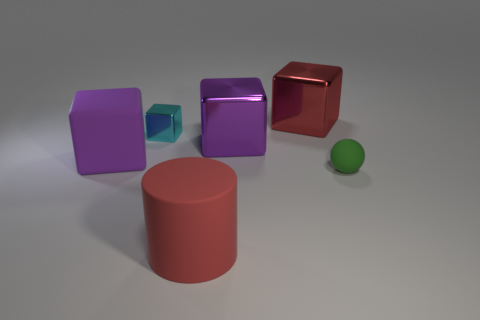There is a red metal block; are there any green matte objects behind it?
Offer a terse response. No. What material is the thing that is the same color as the matte cylinder?
Your response must be concise. Metal. Does the red thing that is in front of the tiny ball have the same material as the large red cube?
Your answer should be compact. No. Are there any big red metal blocks to the left of the rubber object that is behind the small object in front of the purple rubber block?
Keep it short and to the point. No. How many spheres are either green matte objects or purple metal things?
Provide a succinct answer. 1. What material is the large block right of the big purple shiny thing?
Make the answer very short. Metal. The object that is the same color as the rubber cylinder is what size?
Keep it short and to the point. Large. There is a large object that is in front of the green thing; does it have the same color as the big cube behind the large purple metallic block?
Your answer should be very brief. Yes. How many objects are either purple metal objects or big blue metal cylinders?
Ensure brevity in your answer.  1. What number of other things are there of the same shape as the big purple rubber object?
Your answer should be compact. 3. 